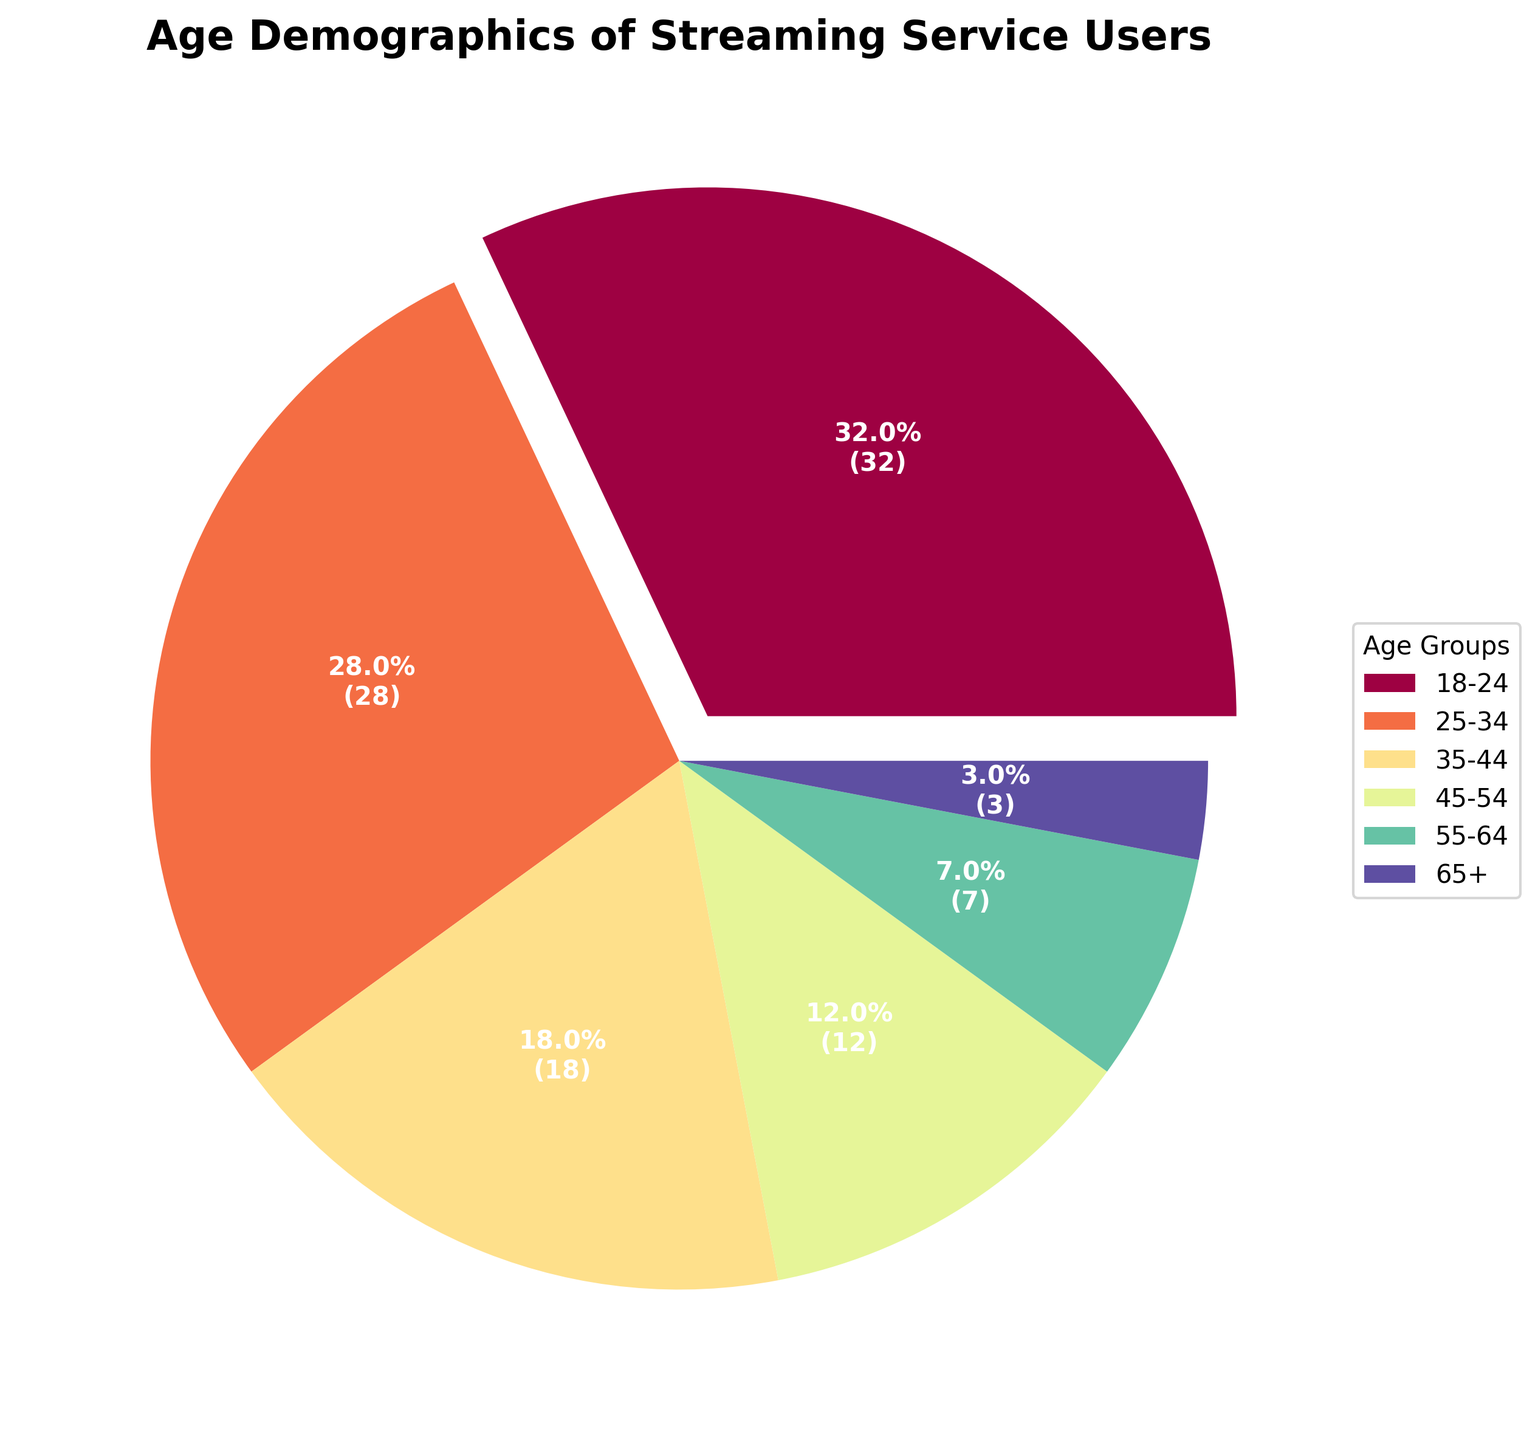What's the percentage of streaming service users who are 25-34 years old? Look at the label corresponding to the 25-34 age group in the pie chart and read off the percentage directly.
Answer: 28% Which age group has the highest percentage of streaming service users? Identify the largest section of the pie chart, which is usually highlighted or separated slightly, and read its label.
Answer: 18-24 How do the percentages of users aged 18-24 and 25-34 compare? Look at the pie chart sections labeled 18-24 and 25-34, and compare their sizes and percentages. The 18-24 age group has a larger percentage.
Answer: 18-24 > 25-34 What is the combined percentage of users who are 35-44 and 45-54 years old? Sum the percentages indicated by the pie chart sections for the 35-44 age group (18%) and the 45-54 age group (12%). 18% + 12% = 30%.
Answer: 30% How many users are 65 years old or older if there are 1000 total users? Identify the percentage for the 65+ age group from the pie chart (3%). Calculate 3% of 1000: 1000 * 0.03 = 30.
Answer: 30 Which age group has the smallest percentage of users? Find the smallest section of the pie chart and read its label.
Answer: 65+ What is the difference in percentage points between users aged 55-64 and 65+? Look at the pie chart sections for the 55-64 and 65+ age groups, and subtract the smaller percentage (3%) from the larger percentage (7%). 7% - 3% = 4%.
Answer: 4% If the chart is colored spectrally from red to blue, what color would most likely represent the age group 18-24? If the pie chart uses a spectral color scheme, the largest segment (18-24) is likely to be on the red end of the spectrum.
Answer: Red 